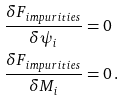Convert formula to latex. <formula><loc_0><loc_0><loc_500><loc_500>\frac { \delta F _ { i m p u r i t i e s } } { \delta \psi _ { i } } & = 0 \\ \frac { \delta F _ { i m p u r i t i e s } } { \delta M _ { i } } & = 0 \, . \\</formula> 